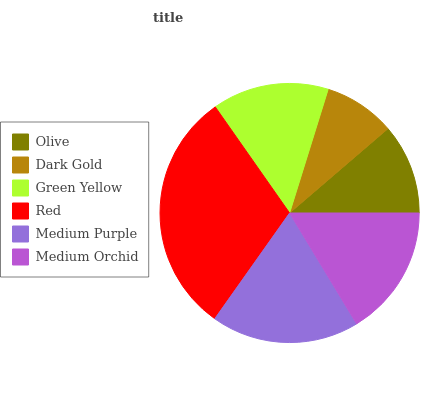Is Dark Gold the minimum?
Answer yes or no. Yes. Is Red the maximum?
Answer yes or no. Yes. Is Green Yellow the minimum?
Answer yes or no. No. Is Green Yellow the maximum?
Answer yes or no. No. Is Green Yellow greater than Dark Gold?
Answer yes or no. Yes. Is Dark Gold less than Green Yellow?
Answer yes or no. Yes. Is Dark Gold greater than Green Yellow?
Answer yes or no. No. Is Green Yellow less than Dark Gold?
Answer yes or no. No. Is Medium Orchid the high median?
Answer yes or no. Yes. Is Green Yellow the low median?
Answer yes or no. Yes. Is Red the high median?
Answer yes or no. No. Is Medium Orchid the low median?
Answer yes or no. No. 